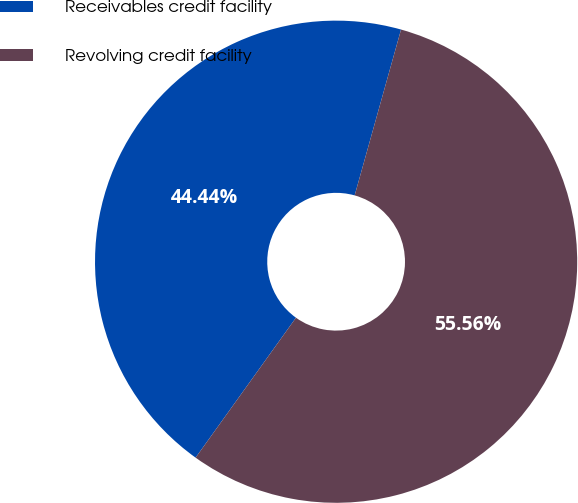<chart> <loc_0><loc_0><loc_500><loc_500><pie_chart><fcel>Receivables credit facility<fcel>Revolving credit facility<nl><fcel>44.44%<fcel>55.56%<nl></chart> 